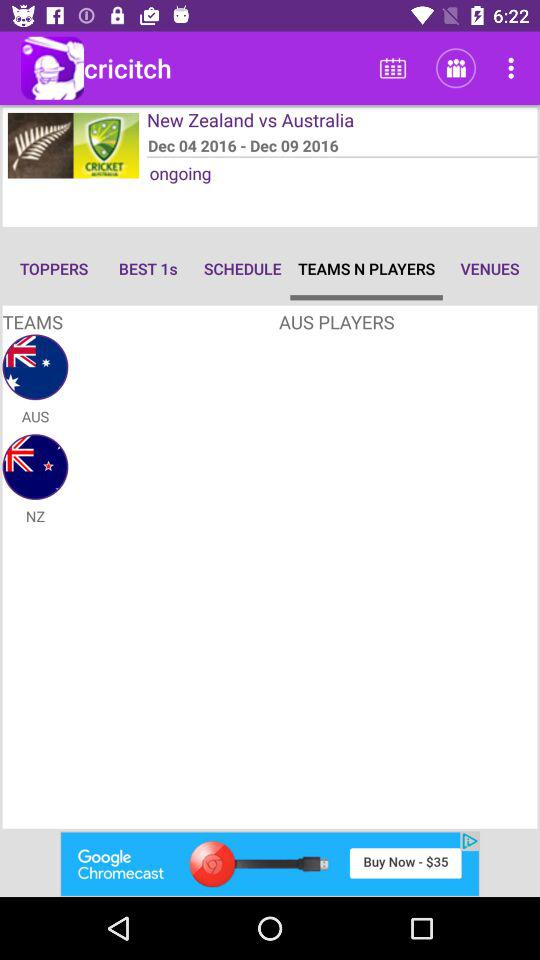What is the application name? The application is "Cricitch". 